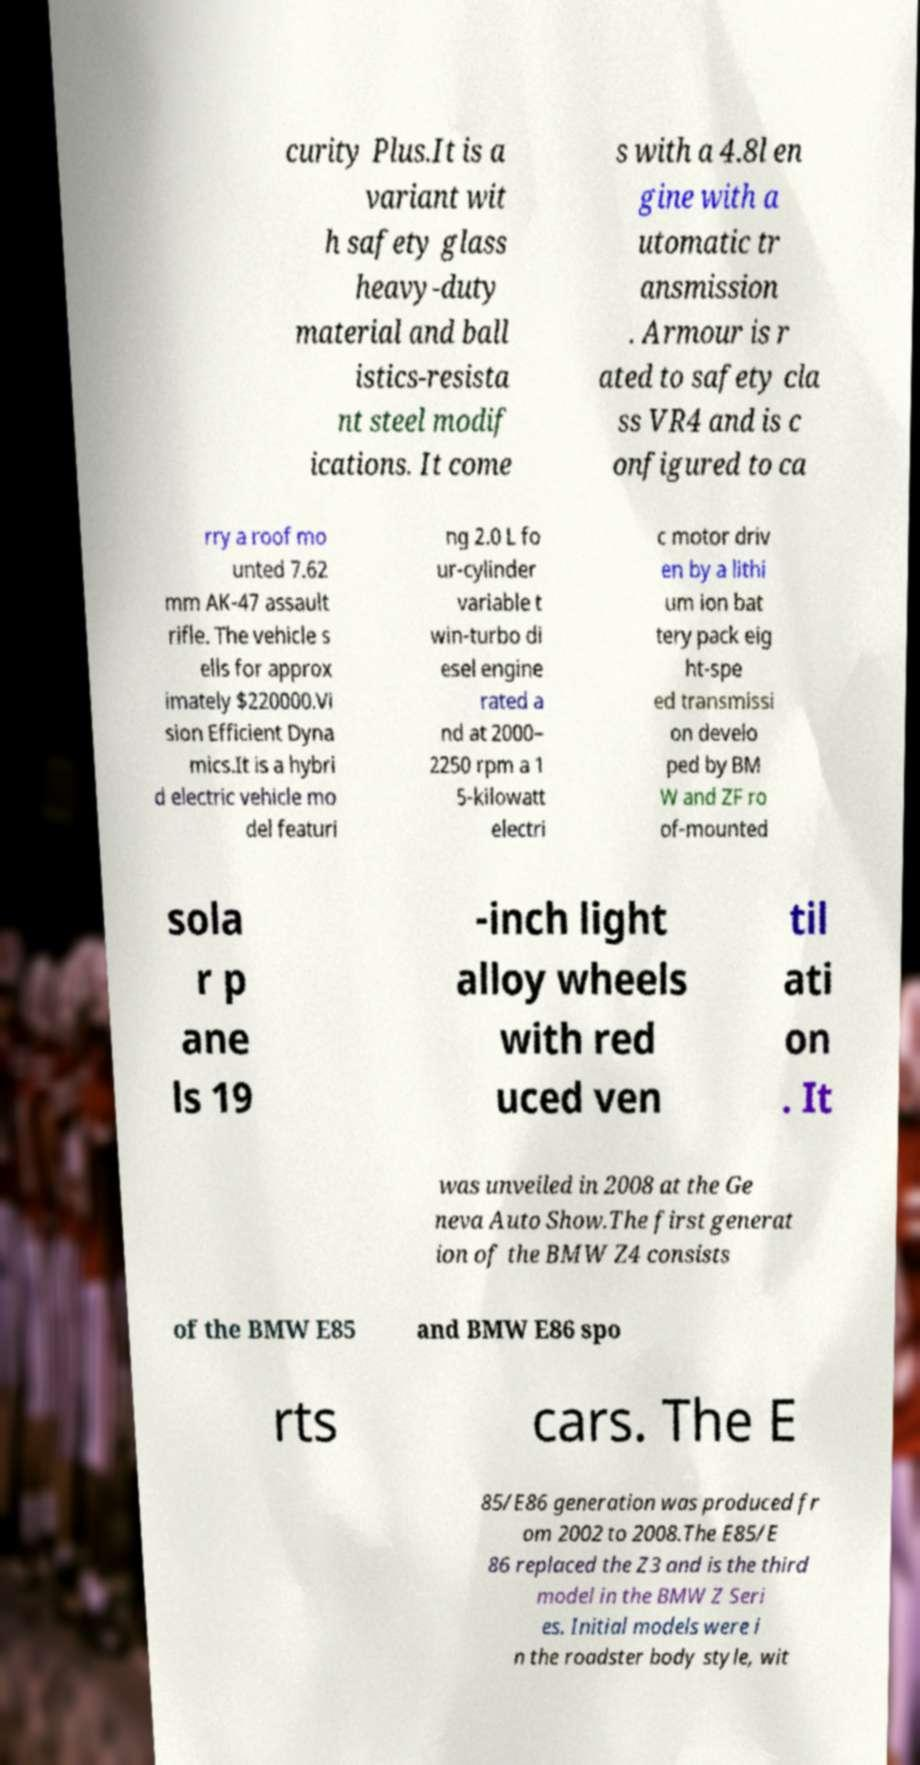Please read and relay the text visible in this image. What does it say? curity Plus.It is a variant wit h safety glass heavy-duty material and ball istics-resista nt steel modif ications. It come s with a 4.8l en gine with a utomatic tr ansmission . Armour is r ated to safety cla ss VR4 and is c onfigured to ca rry a roof mo unted 7.62 mm AK-47 assault rifle. The vehicle s ells for approx imately $220000.Vi sion Efficient Dyna mics.It is a hybri d electric vehicle mo del featuri ng 2.0 L fo ur-cylinder variable t win-turbo di esel engine rated a nd at 2000– 2250 rpm a 1 5-kilowatt electri c motor driv en by a lithi um ion bat tery pack eig ht-spe ed transmissi on develo ped by BM W and ZF ro of-mounted sola r p ane ls 19 -inch light alloy wheels with red uced ven til ati on . It was unveiled in 2008 at the Ge neva Auto Show.The first generat ion of the BMW Z4 consists of the BMW E85 and BMW E86 spo rts cars. The E 85/E86 generation was produced fr om 2002 to 2008.The E85/E 86 replaced the Z3 and is the third model in the BMW Z Seri es. Initial models were i n the roadster body style, wit 